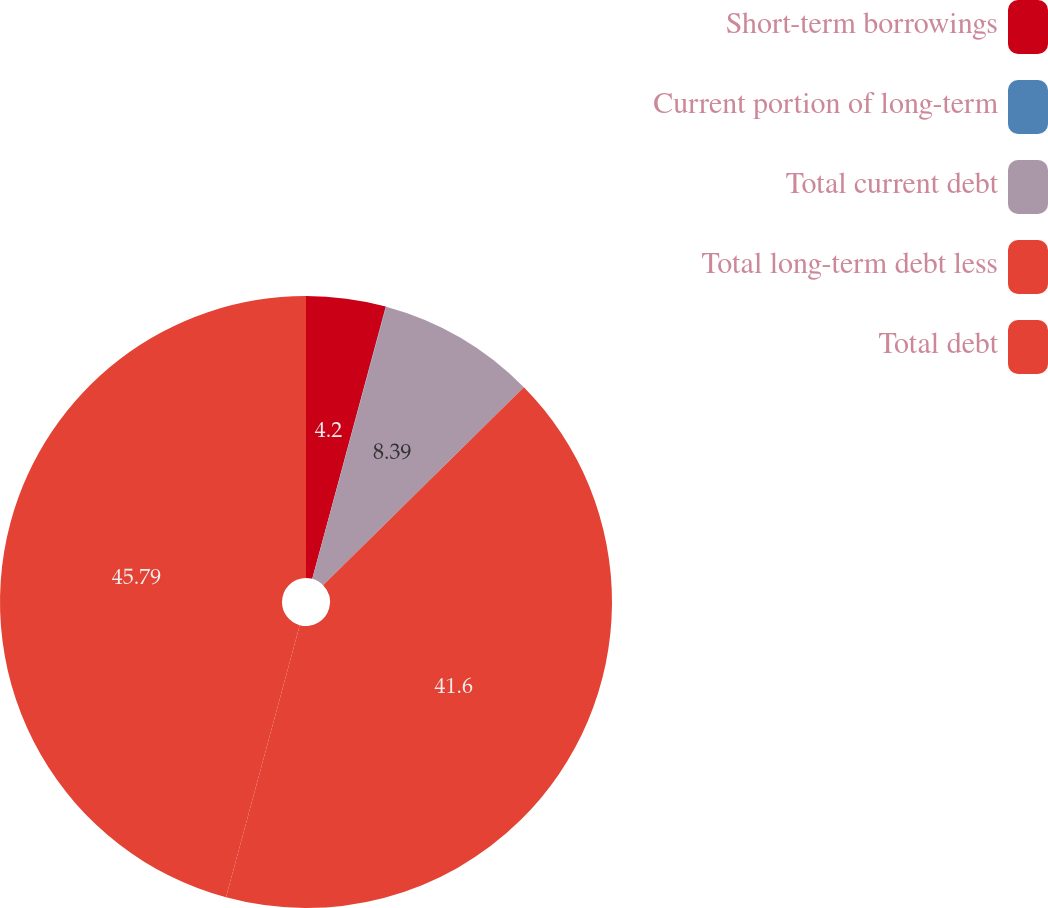<chart> <loc_0><loc_0><loc_500><loc_500><pie_chart><fcel>Short-term borrowings<fcel>Current portion of long-term<fcel>Total current debt<fcel>Total long-term debt less<fcel>Total debt<nl><fcel>4.2%<fcel>0.02%<fcel>8.39%<fcel>41.6%<fcel>45.79%<nl></chart> 